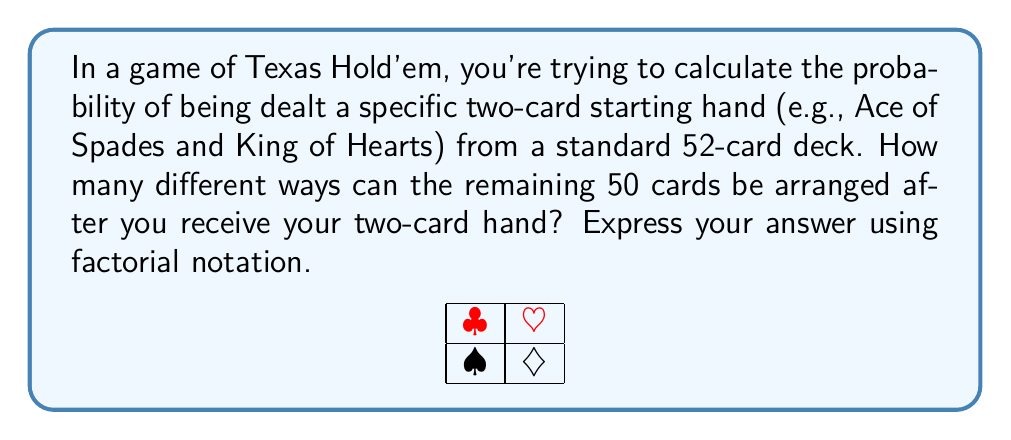Teach me how to tackle this problem. Let's approach this step-by-step:

1) First, we need to understand that we're dealing with permutations of the remaining 50 cards after the two specific cards are dealt.

2) In permutations, the order matters. Each different arrangement of the 50 cards is considered a distinct permutation.

3) The number of permutations of n distinct objects is given by n!.

4) In this case, we have 50 distinct cards to arrange.

5) Therefore, the number of ways to arrange 50 cards is simply 50!.

6) We can express this mathematically as:

   $$P(50) = 50!$$

   Where P(50) represents the number of permutations of 50 objects.

7) It's important to note that 50! is an extremely large number. In fact:

   $$50! \approx 3.04 \times 10^{64}$$

This immense number of possible arrangements underscores why intuition and reading opponents are crucial in poker, as the sheer number of possible card distributions is astronomically large.
Answer: 50! 